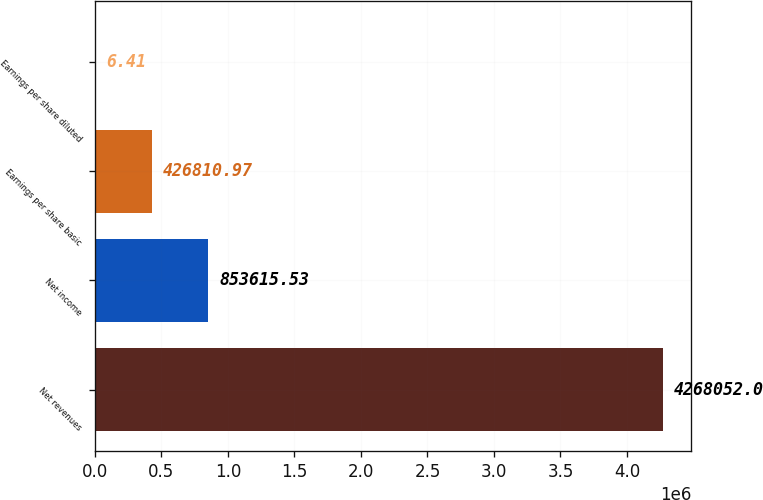Convert chart to OTSL. <chart><loc_0><loc_0><loc_500><loc_500><bar_chart><fcel>Net revenues<fcel>Net income<fcel>Earnings per share basic<fcel>Earnings per share diluted<nl><fcel>4.26805e+06<fcel>853616<fcel>426811<fcel>6.41<nl></chart> 